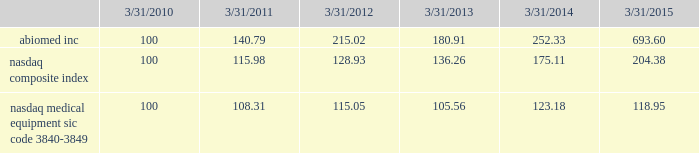Performance graph the following graph compares the yearly change in the cumulative total stockholder return for our last five full fiscal years , based upon the market price of our common stock , with the cumulative total return on a nasdaq composite index ( u.s .
Companies ) and a peer group , the nasdaq medical equipment-sic code 3840-3849 index , which is comprised of medical equipment companies , for that period .
The performance graph assumes the investment of $ 100 on march 31 , 2010 in our common stock , the nasdaq composite index ( u.s .
Companies ) and the peer group index , and the reinvestment of any and all dividends. .
This graph is not 201csoliciting material 201d under regulation 14a or 14c of the rules promulgated under the securities exchange act of 1934 , is not deemed filed with the securities and exchange commission and is not to be incorporated by reference in any of our filings under the securities act of 1933 , as amended , or the exchange act whether made before or after the date hereof and irrespective of any general incorporation language in any such filing .
Transfer agent american stock transfer & trust company , 59 maiden lane , new york , ny 10038 , is our stock transfer agent. .
Did abiomed outperform the nasdaq composite index over the five year period? 
Computations: (693.60 > 204.38)
Answer: yes. 